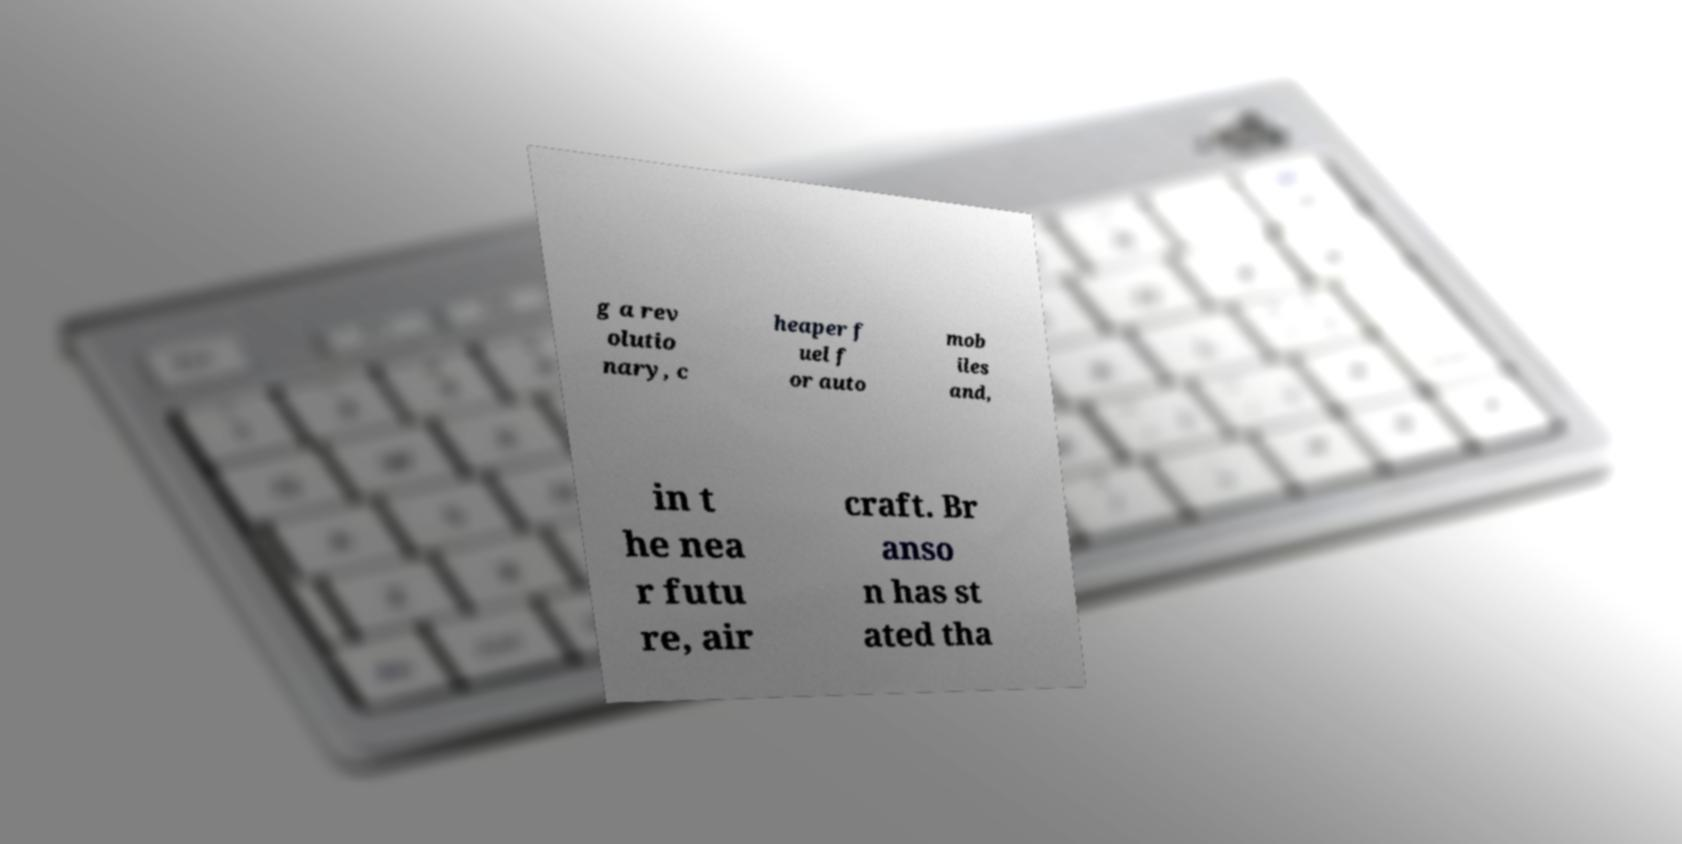For documentation purposes, I need the text within this image transcribed. Could you provide that? g a rev olutio nary, c heaper f uel f or auto mob iles and, in t he nea r futu re, air craft. Br anso n has st ated tha 